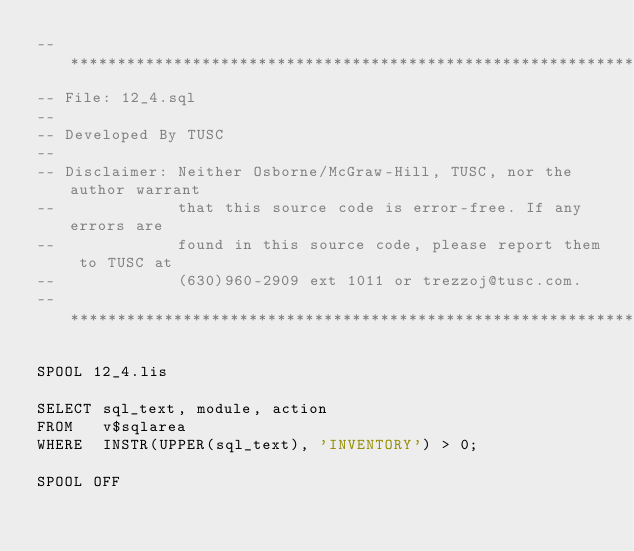Convert code to text. <code><loc_0><loc_0><loc_500><loc_500><_SQL_>-- ***************************************************************************
-- File: 12_4.sql
--
-- Developed By TUSC
--
-- Disclaimer: Neither Osborne/McGraw-Hill, TUSC, nor the author warrant
--             that this source code is error-free. If any errors are
--             found in this source code, please report them to TUSC at
--             (630)960-2909 ext 1011 or trezzoj@tusc.com.
-- ***************************************************************************

SPOOL 12_4.lis

SELECT sql_text, module, action
FROM   v$sqlarea
WHERE  INSTR(UPPER(sql_text), 'INVENTORY') > 0;

SPOOL OFF
</code> 